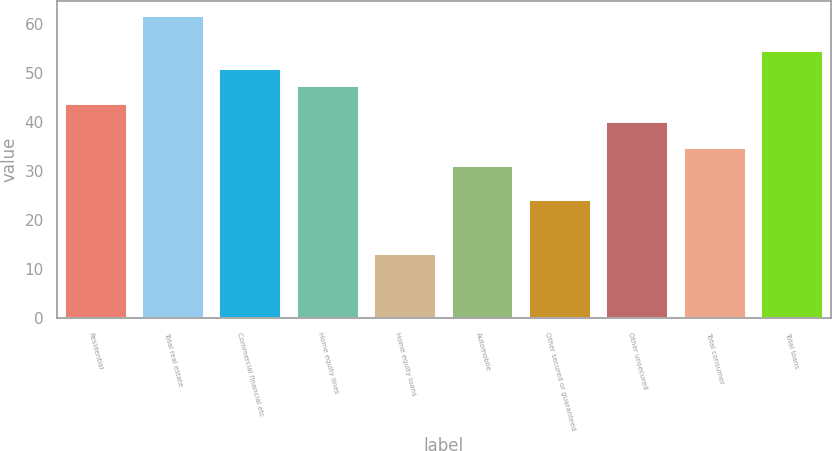Convert chart. <chart><loc_0><loc_0><loc_500><loc_500><bar_chart><fcel>Residential<fcel>Total real estate<fcel>Commercial financial etc<fcel>Home equity lines<fcel>Home equity loans<fcel>Automobile<fcel>Other secured or guaranteed<fcel>Other unsecured<fcel>Total consumer<fcel>Total loans<nl><fcel>43.6<fcel>61.6<fcel>50.8<fcel>47.2<fcel>13<fcel>31<fcel>24<fcel>40<fcel>34.6<fcel>54.4<nl></chart> 